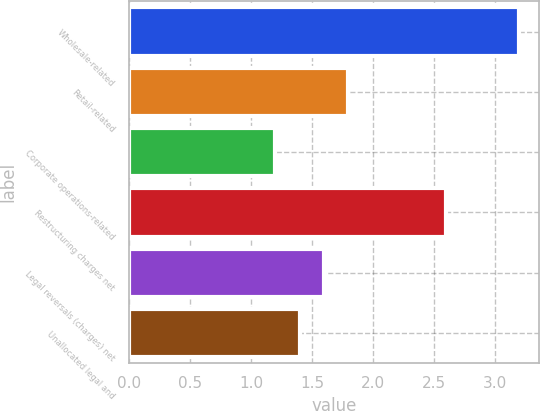<chart> <loc_0><loc_0><loc_500><loc_500><bar_chart><fcel>Wholesale-related<fcel>Retail-related<fcel>Corporate operations-related<fcel>Restructuring charges net<fcel>Legal reversals (charges) net<fcel>Unallocated legal and<nl><fcel>3.2<fcel>1.8<fcel>1.2<fcel>2.6<fcel>1.6<fcel>1.4<nl></chart> 